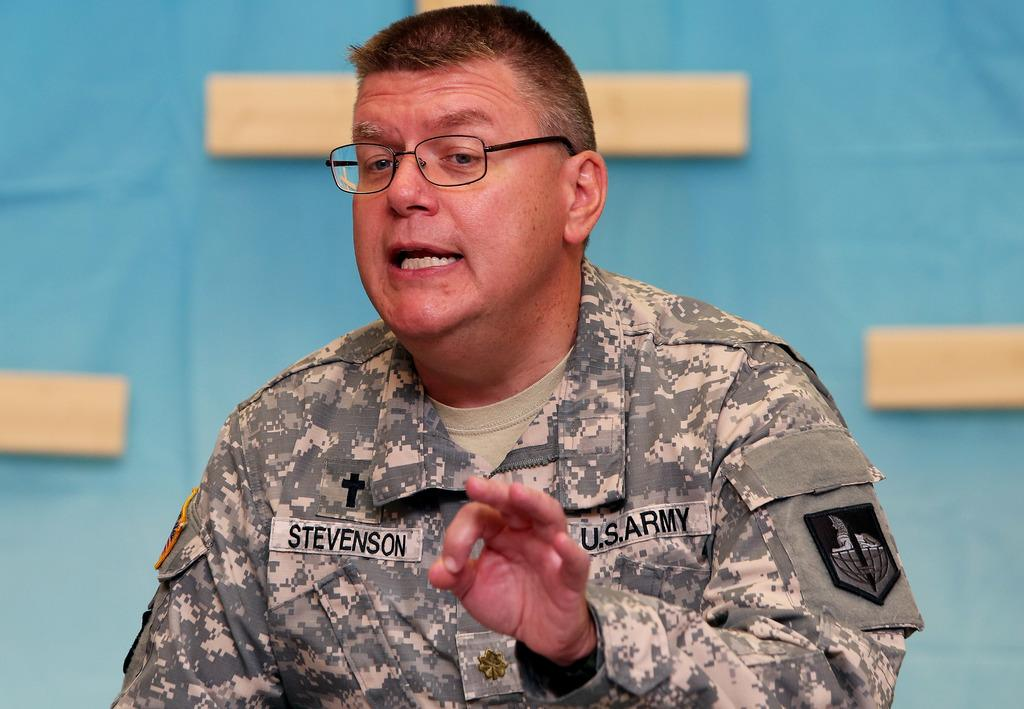What is the main subject of the image? The main subject of the image is a man. Can you describe the man's appearance in the image? The man is wearing spectacles in the image. What type of beetle can be seen crawling on the man's spectacles in the image? There is no beetle present on the man's spectacles in the image. 